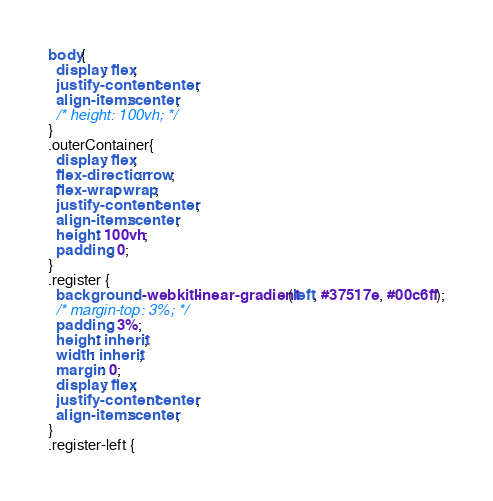<code> <loc_0><loc_0><loc_500><loc_500><_CSS_>body{
  display: flex;
  justify-content: center;
  align-items: center;
  /* height: 100vh; */
}
.outerContainer{
  display: flex;
  flex-direction: row;
  flex-wrap: wrap;
  justify-content: center;
  align-items: center;
  height: 100vh;
  padding: 0;
}
.register {
  background: -webkit-linear-gradient(left, #37517e, #00c6ff);
  /* margin-top: 3%; */
  padding: 3%;
  height: inherit;
  width: inherit;
  margin: 0;
  display: flex;
  justify-content: center;
  align-items: center;
}
.register-left {</code> 